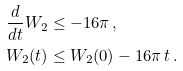Convert formula to latex. <formula><loc_0><loc_0><loc_500><loc_500>\frac { d } { d t } W _ { 2 } & \leq - 1 6 \pi \, , \\ W _ { 2 } ( t ) & \leq W _ { 2 } ( 0 ) - 1 6 \pi \, t \, .</formula> 